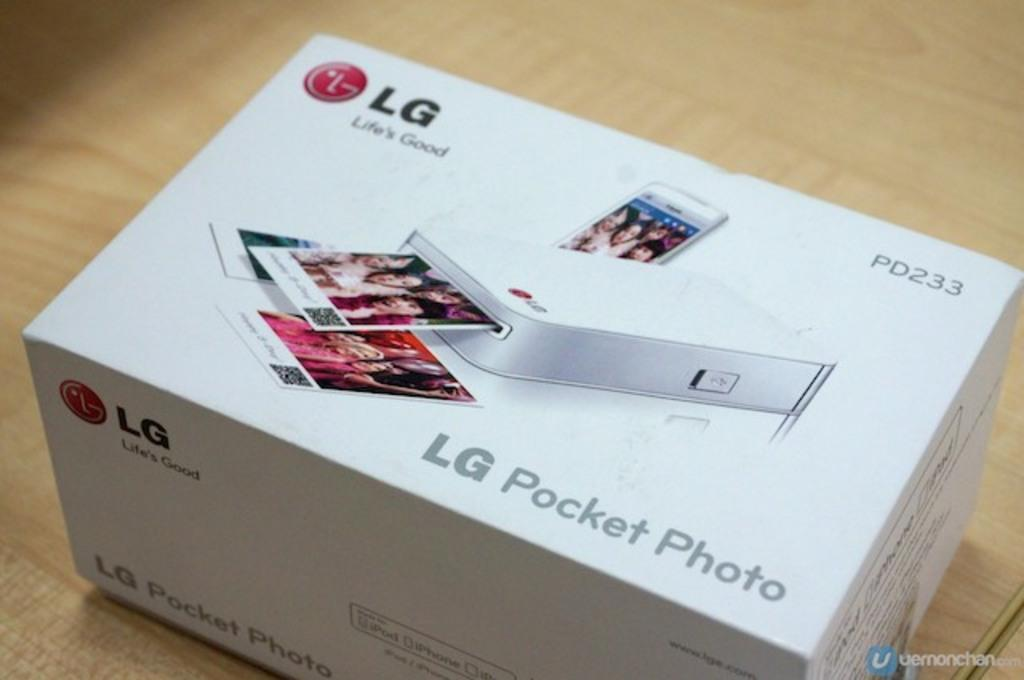<image>
Offer a succinct explanation of the picture presented. boxed lg pocket photo printer model pd233 on a tabletop 